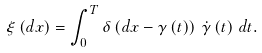Convert formula to latex. <formula><loc_0><loc_0><loc_500><loc_500>\xi \left ( d x \right ) = \int _ { 0 } ^ { T } \delta \left ( d x - \gamma \left ( t \right ) \right ) \, \dot { \gamma } \left ( t \right ) \, d t .</formula> 